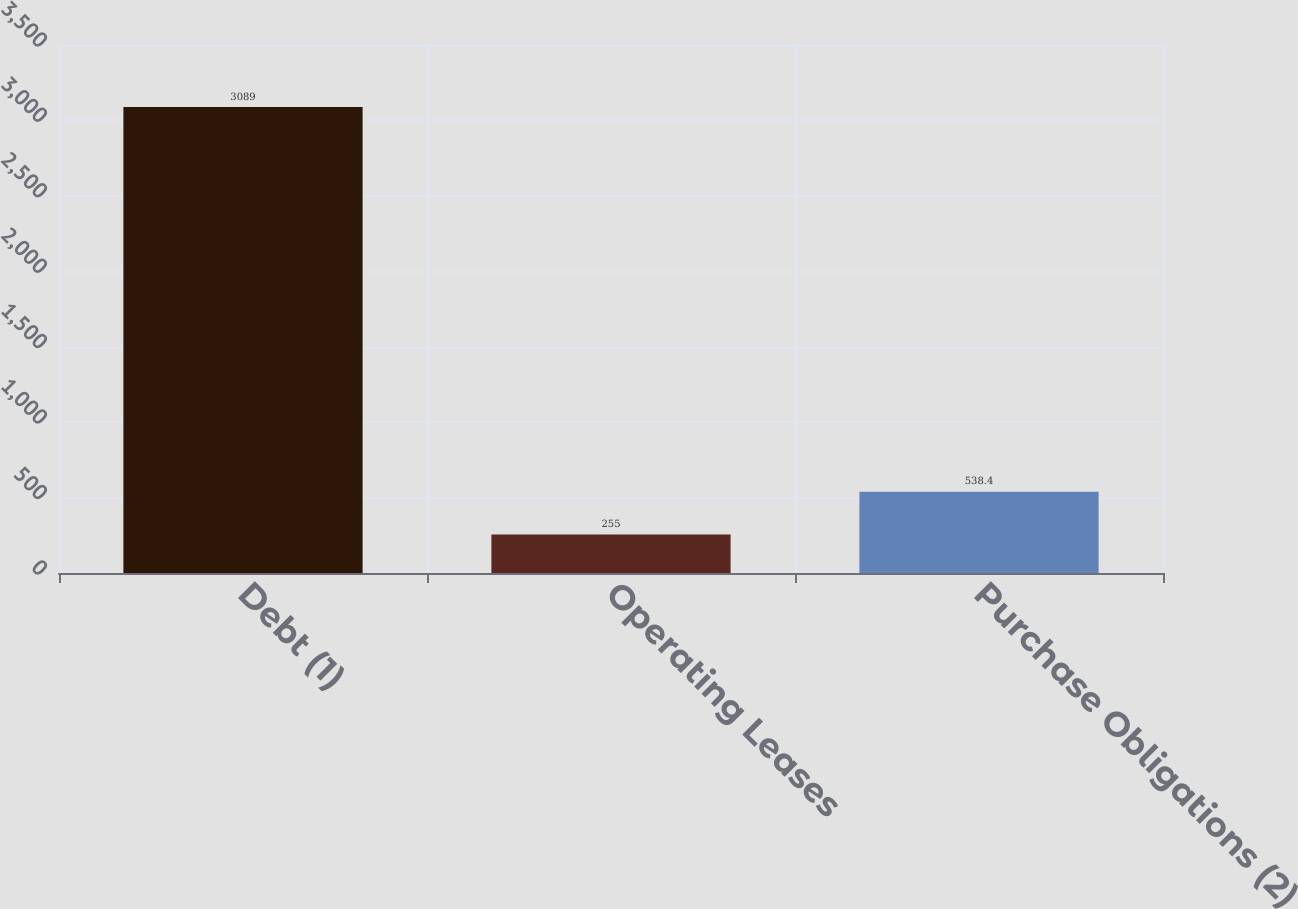Convert chart to OTSL. <chart><loc_0><loc_0><loc_500><loc_500><bar_chart><fcel>Debt (1)<fcel>Operating Leases<fcel>Purchase Obligations (2)<nl><fcel>3089<fcel>255<fcel>538.4<nl></chart> 